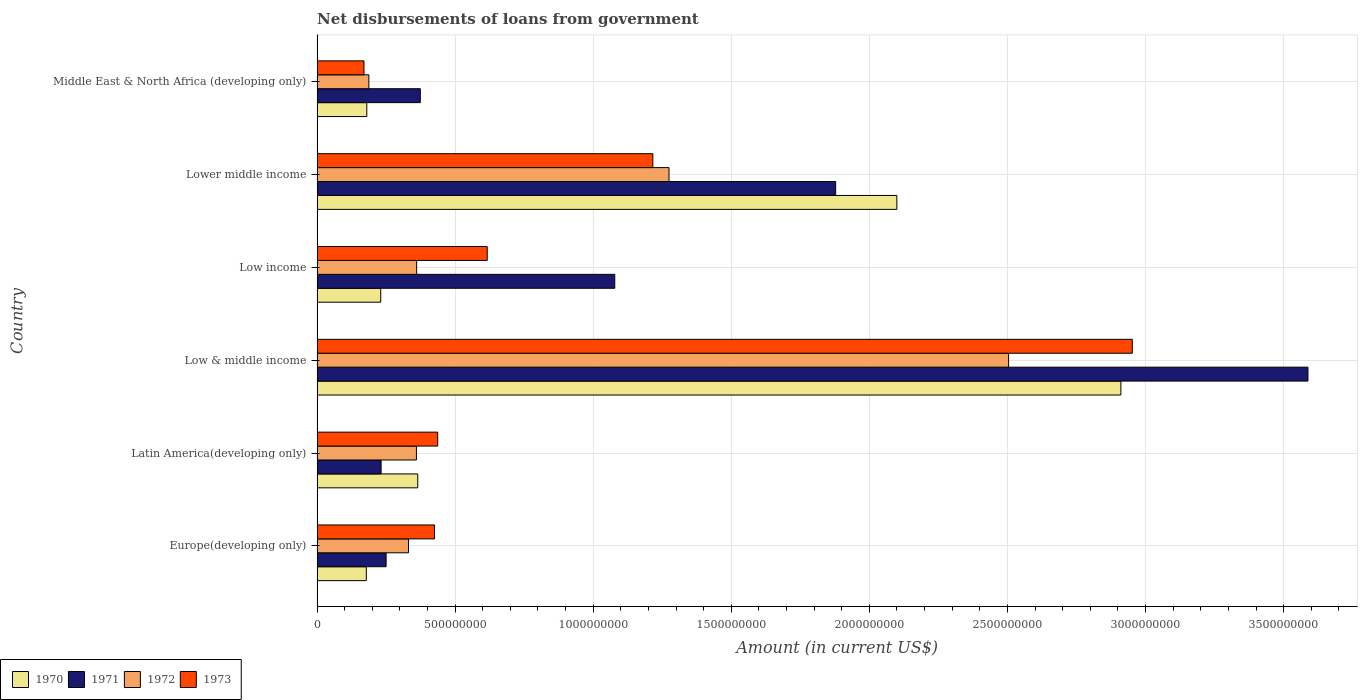Are the number of bars on each tick of the Y-axis equal?
Offer a terse response. Yes. How many bars are there on the 5th tick from the top?
Your response must be concise. 4. How many bars are there on the 5th tick from the bottom?
Your answer should be very brief. 4. What is the label of the 2nd group of bars from the top?
Your response must be concise. Lower middle income. What is the amount of loan disbursed from government in 1971 in Latin America(developing only)?
Provide a short and direct response. 2.32e+08. Across all countries, what is the maximum amount of loan disbursed from government in 1971?
Offer a very short reply. 3.59e+09. Across all countries, what is the minimum amount of loan disbursed from government in 1971?
Ensure brevity in your answer.  2.32e+08. In which country was the amount of loan disbursed from government in 1970 maximum?
Ensure brevity in your answer.  Low & middle income. In which country was the amount of loan disbursed from government in 1970 minimum?
Your answer should be compact. Europe(developing only). What is the total amount of loan disbursed from government in 1971 in the graph?
Provide a succinct answer. 7.40e+09. What is the difference between the amount of loan disbursed from government in 1973 in Low & middle income and that in Lower middle income?
Your answer should be very brief. 1.74e+09. What is the difference between the amount of loan disbursed from government in 1970 in Middle East & North Africa (developing only) and the amount of loan disbursed from government in 1973 in Low income?
Make the answer very short. -4.36e+08. What is the average amount of loan disbursed from government in 1973 per country?
Give a very brief answer. 9.69e+08. What is the difference between the amount of loan disbursed from government in 1972 and amount of loan disbursed from government in 1970 in Lower middle income?
Provide a succinct answer. -8.25e+08. In how many countries, is the amount of loan disbursed from government in 1973 greater than 1300000000 US$?
Make the answer very short. 1. What is the ratio of the amount of loan disbursed from government in 1971 in Europe(developing only) to that in Middle East & North Africa (developing only)?
Make the answer very short. 0.67. Is the difference between the amount of loan disbursed from government in 1972 in Latin America(developing only) and Low & middle income greater than the difference between the amount of loan disbursed from government in 1970 in Latin America(developing only) and Low & middle income?
Your answer should be compact. Yes. What is the difference between the highest and the second highest amount of loan disbursed from government in 1971?
Make the answer very short. 1.71e+09. What is the difference between the highest and the lowest amount of loan disbursed from government in 1970?
Offer a very short reply. 2.73e+09. In how many countries, is the amount of loan disbursed from government in 1972 greater than the average amount of loan disbursed from government in 1972 taken over all countries?
Provide a succinct answer. 2. Is it the case that in every country, the sum of the amount of loan disbursed from government in 1970 and amount of loan disbursed from government in 1972 is greater than the amount of loan disbursed from government in 1971?
Offer a very short reply. No. How many bars are there?
Your response must be concise. 24. Are all the bars in the graph horizontal?
Keep it short and to the point. Yes. How many countries are there in the graph?
Your response must be concise. 6. Are the values on the major ticks of X-axis written in scientific E-notation?
Provide a succinct answer. No. Does the graph contain grids?
Your answer should be very brief. Yes. Where does the legend appear in the graph?
Offer a very short reply. Bottom left. How many legend labels are there?
Provide a succinct answer. 4. How are the legend labels stacked?
Your answer should be very brief. Horizontal. What is the title of the graph?
Provide a succinct answer. Net disbursements of loans from government. What is the label or title of the X-axis?
Keep it short and to the point. Amount (in current US$). What is the label or title of the Y-axis?
Your answer should be very brief. Country. What is the Amount (in current US$) of 1970 in Europe(developing only)?
Ensure brevity in your answer.  1.78e+08. What is the Amount (in current US$) of 1971 in Europe(developing only)?
Give a very brief answer. 2.50e+08. What is the Amount (in current US$) of 1972 in Europe(developing only)?
Keep it short and to the point. 3.31e+08. What is the Amount (in current US$) in 1973 in Europe(developing only)?
Your answer should be compact. 4.25e+08. What is the Amount (in current US$) in 1970 in Latin America(developing only)?
Offer a terse response. 3.65e+08. What is the Amount (in current US$) of 1971 in Latin America(developing only)?
Provide a succinct answer. 2.32e+08. What is the Amount (in current US$) in 1972 in Latin America(developing only)?
Offer a terse response. 3.60e+08. What is the Amount (in current US$) in 1973 in Latin America(developing only)?
Give a very brief answer. 4.37e+08. What is the Amount (in current US$) in 1970 in Low & middle income?
Provide a succinct answer. 2.91e+09. What is the Amount (in current US$) of 1971 in Low & middle income?
Make the answer very short. 3.59e+09. What is the Amount (in current US$) of 1972 in Low & middle income?
Keep it short and to the point. 2.50e+09. What is the Amount (in current US$) of 1973 in Low & middle income?
Your answer should be compact. 2.95e+09. What is the Amount (in current US$) in 1970 in Low income?
Your answer should be very brief. 2.31e+08. What is the Amount (in current US$) in 1971 in Low income?
Keep it short and to the point. 1.08e+09. What is the Amount (in current US$) of 1972 in Low income?
Your answer should be very brief. 3.61e+08. What is the Amount (in current US$) in 1973 in Low income?
Make the answer very short. 6.16e+08. What is the Amount (in current US$) of 1970 in Lower middle income?
Your answer should be very brief. 2.10e+09. What is the Amount (in current US$) in 1971 in Lower middle income?
Give a very brief answer. 1.88e+09. What is the Amount (in current US$) of 1972 in Lower middle income?
Offer a very short reply. 1.27e+09. What is the Amount (in current US$) of 1973 in Lower middle income?
Make the answer very short. 1.22e+09. What is the Amount (in current US$) of 1970 in Middle East & North Africa (developing only)?
Provide a short and direct response. 1.80e+08. What is the Amount (in current US$) in 1971 in Middle East & North Africa (developing only)?
Your answer should be very brief. 3.74e+08. What is the Amount (in current US$) in 1972 in Middle East & North Africa (developing only)?
Offer a very short reply. 1.88e+08. What is the Amount (in current US$) of 1973 in Middle East & North Africa (developing only)?
Provide a short and direct response. 1.70e+08. Across all countries, what is the maximum Amount (in current US$) in 1970?
Offer a terse response. 2.91e+09. Across all countries, what is the maximum Amount (in current US$) in 1971?
Ensure brevity in your answer.  3.59e+09. Across all countries, what is the maximum Amount (in current US$) of 1972?
Keep it short and to the point. 2.50e+09. Across all countries, what is the maximum Amount (in current US$) of 1973?
Make the answer very short. 2.95e+09. Across all countries, what is the minimum Amount (in current US$) in 1970?
Your response must be concise. 1.78e+08. Across all countries, what is the minimum Amount (in current US$) in 1971?
Your response must be concise. 2.32e+08. Across all countries, what is the minimum Amount (in current US$) in 1972?
Provide a short and direct response. 1.88e+08. Across all countries, what is the minimum Amount (in current US$) in 1973?
Your answer should be compact. 1.70e+08. What is the total Amount (in current US$) in 1970 in the graph?
Offer a very short reply. 5.96e+09. What is the total Amount (in current US$) in 1971 in the graph?
Your answer should be compact. 7.40e+09. What is the total Amount (in current US$) of 1972 in the graph?
Give a very brief answer. 5.02e+09. What is the total Amount (in current US$) of 1973 in the graph?
Your response must be concise. 5.82e+09. What is the difference between the Amount (in current US$) of 1970 in Europe(developing only) and that in Latin America(developing only)?
Offer a terse response. -1.86e+08. What is the difference between the Amount (in current US$) in 1971 in Europe(developing only) and that in Latin America(developing only)?
Your answer should be compact. 1.82e+07. What is the difference between the Amount (in current US$) of 1972 in Europe(developing only) and that in Latin America(developing only)?
Make the answer very short. -2.88e+07. What is the difference between the Amount (in current US$) in 1973 in Europe(developing only) and that in Latin America(developing only)?
Provide a succinct answer. -1.16e+07. What is the difference between the Amount (in current US$) of 1970 in Europe(developing only) and that in Low & middle income?
Make the answer very short. -2.73e+09. What is the difference between the Amount (in current US$) in 1971 in Europe(developing only) and that in Low & middle income?
Offer a very short reply. -3.34e+09. What is the difference between the Amount (in current US$) of 1972 in Europe(developing only) and that in Low & middle income?
Make the answer very short. -2.17e+09. What is the difference between the Amount (in current US$) of 1973 in Europe(developing only) and that in Low & middle income?
Your answer should be compact. -2.53e+09. What is the difference between the Amount (in current US$) in 1970 in Europe(developing only) and that in Low income?
Provide a short and direct response. -5.22e+07. What is the difference between the Amount (in current US$) in 1971 in Europe(developing only) and that in Low income?
Your answer should be compact. -8.28e+08. What is the difference between the Amount (in current US$) of 1972 in Europe(developing only) and that in Low income?
Offer a very short reply. -2.96e+07. What is the difference between the Amount (in current US$) in 1973 in Europe(developing only) and that in Low income?
Your answer should be compact. -1.91e+08. What is the difference between the Amount (in current US$) in 1970 in Europe(developing only) and that in Lower middle income?
Ensure brevity in your answer.  -1.92e+09. What is the difference between the Amount (in current US$) in 1971 in Europe(developing only) and that in Lower middle income?
Offer a very short reply. -1.63e+09. What is the difference between the Amount (in current US$) in 1972 in Europe(developing only) and that in Lower middle income?
Your response must be concise. -9.43e+08. What is the difference between the Amount (in current US$) in 1973 in Europe(developing only) and that in Lower middle income?
Offer a very short reply. -7.91e+08. What is the difference between the Amount (in current US$) of 1970 in Europe(developing only) and that in Middle East & North Africa (developing only)?
Provide a short and direct response. -1.75e+06. What is the difference between the Amount (in current US$) in 1971 in Europe(developing only) and that in Middle East & North Africa (developing only)?
Keep it short and to the point. -1.24e+08. What is the difference between the Amount (in current US$) in 1972 in Europe(developing only) and that in Middle East & North Africa (developing only)?
Keep it short and to the point. 1.43e+08. What is the difference between the Amount (in current US$) in 1973 in Europe(developing only) and that in Middle East & North Africa (developing only)?
Make the answer very short. 2.55e+08. What is the difference between the Amount (in current US$) of 1970 in Latin America(developing only) and that in Low & middle income?
Ensure brevity in your answer.  -2.55e+09. What is the difference between the Amount (in current US$) in 1971 in Latin America(developing only) and that in Low & middle income?
Provide a short and direct response. -3.36e+09. What is the difference between the Amount (in current US$) in 1972 in Latin America(developing only) and that in Low & middle income?
Offer a terse response. -2.14e+09. What is the difference between the Amount (in current US$) of 1973 in Latin America(developing only) and that in Low & middle income?
Offer a very short reply. -2.52e+09. What is the difference between the Amount (in current US$) in 1970 in Latin America(developing only) and that in Low income?
Keep it short and to the point. 1.34e+08. What is the difference between the Amount (in current US$) in 1971 in Latin America(developing only) and that in Low income?
Offer a terse response. -8.46e+08. What is the difference between the Amount (in current US$) of 1972 in Latin America(developing only) and that in Low income?
Your answer should be compact. -7.43e+05. What is the difference between the Amount (in current US$) in 1973 in Latin America(developing only) and that in Low income?
Make the answer very short. -1.79e+08. What is the difference between the Amount (in current US$) of 1970 in Latin America(developing only) and that in Lower middle income?
Keep it short and to the point. -1.73e+09. What is the difference between the Amount (in current US$) of 1971 in Latin America(developing only) and that in Lower middle income?
Keep it short and to the point. -1.65e+09. What is the difference between the Amount (in current US$) of 1972 in Latin America(developing only) and that in Lower middle income?
Your answer should be very brief. -9.15e+08. What is the difference between the Amount (in current US$) of 1973 in Latin America(developing only) and that in Lower middle income?
Offer a terse response. -7.79e+08. What is the difference between the Amount (in current US$) of 1970 in Latin America(developing only) and that in Middle East & North Africa (developing only)?
Make the answer very short. 1.85e+08. What is the difference between the Amount (in current US$) of 1971 in Latin America(developing only) and that in Middle East & North Africa (developing only)?
Give a very brief answer. -1.42e+08. What is the difference between the Amount (in current US$) in 1972 in Latin America(developing only) and that in Middle East & North Africa (developing only)?
Make the answer very short. 1.72e+08. What is the difference between the Amount (in current US$) in 1973 in Latin America(developing only) and that in Middle East & North Africa (developing only)?
Offer a very short reply. 2.67e+08. What is the difference between the Amount (in current US$) of 1970 in Low & middle income and that in Low income?
Offer a very short reply. 2.68e+09. What is the difference between the Amount (in current US$) in 1971 in Low & middle income and that in Low income?
Provide a short and direct response. 2.51e+09. What is the difference between the Amount (in current US$) of 1972 in Low & middle income and that in Low income?
Provide a short and direct response. 2.14e+09. What is the difference between the Amount (in current US$) of 1973 in Low & middle income and that in Low income?
Offer a terse response. 2.34e+09. What is the difference between the Amount (in current US$) in 1970 in Low & middle income and that in Lower middle income?
Make the answer very short. 8.11e+08. What is the difference between the Amount (in current US$) in 1971 in Low & middle income and that in Lower middle income?
Provide a short and direct response. 1.71e+09. What is the difference between the Amount (in current US$) in 1972 in Low & middle income and that in Lower middle income?
Offer a very short reply. 1.23e+09. What is the difference between the Amount (in current US$) in 1973 in Low & middle income and that in Lower middle income?
Ensure brevity in your answer.  1.74e+09. What is the difference between the Amount (in current US$) of 1970 in Low & middle income and that in Middle East & North Africa (developing only)?
Keep it short and to the point. 2.73e+09. What is the difference between the Amount (in current US$) of 1971 in Low & middle income and that in Middle East & North Africa (developing only)?
Your answer should be very brief. 3.21e+09. What is the difference between the Amount (in current US$) of 1972 in Low & middle income and that in Middle East & North Africa (developing only)?
Keep it short and to the point. 2.32e+09. What is the difference between the Amount (in current US$) in 1973 in Low & middle income and that in Middle East & North Africa (developing only)?
Give a very brief answer. 2.78e+09. What is the difference between the Amount (in current US$) in 1970 in Low income and that in Lower middle income?
Ensure brevity in your answer.  -1.87e+09. What is the difference between the Amount (in current US$) in 1971 in Low income and that in Lower middle income?
Give a very brief answer. -8.00e+08. What is the difference between the Amount (in current US$) of 1972 in Low income and that in Lower middle income?
Keep it short and to the point. -9.14e+08. What is the difference between the Amount (in current US$) in 1973 in Low income and that in Lower middle income?
Keep it short and to the point. -6.00e+08. What is the difference between the Amount (in current US$) of 1970 in Low income and that in Middle East & North Africa (developing only)?
Offer a very short reply. 5.04e+07. What is the difference between the Amount (in current US$) of 1971 in Low income and that in Middle East & North Africa (developing only)?
Your response must be concise. 7.04e+08. What is the difference between the Amount (in current US$) in 1972 in Low income and that in Middle East & North Africa (developing only)?
Your answer should be compact. 1.73e+08. What is the difference between the Amount (in current US$) of 1973 in Low income and that in Middle East & North Africa (developing only)?
Your answer should be very brief. 4.46e+08. What is the difference between the Amount (in current US$) of 1970 in Lower middle income and that in Middle East & North Africa (developing only)?
Make the answer very short. 1.92e+09. What is the difference between the Amount (in current US$) of 1971 in Lower middle income and that in Middle East & North Africa (developing only)?
Offer a terse response. 1.50e+09. What is the difference between the Amount (in current US$) of 1972 in Lower middle income and that in Middle East & North Africa (developing only)?
Offer a very short reply. 1.09e+09. What is the difference between the Amount (in current US$) of 1973 in Lower middle income and that in Middle East & North Africa (developing only)?
Provide a short and direct response. 1.05e+09. What is the difference between the Amount (in current US$) in 1970 in Europe(developing only) and the Amount (in current US$) in 1971 in Latin America(developing only)?
Make the answer very short. -5.36e+07. What is the difference between the Amount (in current US$) in 1970 in Europe(developing only) and the Amount (in current US$) in 1972 in Latin America(developing only)?
Offer a very short reply. -1.82e+08. What is the difference between the Amount (in current US$) of 1970 in Europe(developing only) and the Amount (in current US$) of 1973 in Latin America(developing only)?
Keep it short and to the point. -2.59e+08. What is the difference between the Amount (in current US$) of 1971 in Europe(developing only) and the Amount (in current US$) of 1972 in Latin America(developing only)?
Your answer should be compact. -1.10e+08. What is the difference between the Amount (in current US$) of 1971 in Europe(developing only) and the Amount (in current US$) of 1973 in Latin America(developing only)?
Provide a short and direct response. -1.87e+08. What is the difference between the Amount (in current US$) in 1972 in Europe(developing only) and the Amount (in current US$) in 1973 in Latin America(developing only)?
Keep it short and to the point. -1.06e+08. What is the difference between the Amount (in current US$) in 1970 in Europe(developing only) and the Amount (in current US$) in 1971 in Low & middle income?
Ensure brevity in your answer.  -3.41e+09. What is the difference between the Amount (in current US$) in 1970 in Europe(developing only) and the Amount (in current US$) in 1972 in Low & middle income?
Your answer should be compact. -2.33e+09. What is the difference between the Amount (in current US$) in 1970 in Europe(developing only) and the Amount (in current US$) in 1973 in Low & middle income?
Make the answer very short. -2.77e+09. What is the difference between the Amount (in current US$) in 1971 in Europe(developing only) and the Amount (in current US$) in 1972 in Low & middle income?
Provide a succinct answer. -2.25e+09. What is the difference between the Amount (in current US$) of 1971 in Europe(developing only) and the Amount (in current US$) of 1973 in Low & middle income?
Offer a very short reply. -2.70e+09. What is the difference between the Amount (in current US$) of 1972 in Europe(developing only) and the Amount (in current US$) of 1973 in Low & middle income?
Offer a terse response. -2.62e+09. What is the difference between the Amount (in current US$) in 1970 in Europe(developing only) and the Amount (in current US$) in 1971 in Low income?
Give a very brief answer. -9.00e+08. What is the difference between the Amount (in current US$) in 1970 in Europe(developing only) and the Amount (in current US$) in 1972 in Low income?
Ensure brevity in your answer.  -1.82e+08. What is the difference between the Amount (in current US$) in 1970 in Europe(developing only) and the Amount (in current US$) in 1973 in Low income?
Your answer should be compact. -4.38e+08. What is the difference between the Amount (in current US$) in 1971 in Europe(developing only) and the Amount (in current US$) in 1972 in Low income?
Provide a short and direct response. -1.11e+08. What is the difference between the Amount (in current US$) of 1971 in Europe(developing only) and the Amount (in current US$) of 1973 in Low income?
Keep it short and to the point. -3.66e+08. What is the difference between the Amount (in current US$) in 1972 in Europe(developing only) and the Amount (in current US$) in 1973 in Low income?
Keep it short and to the point. -2.85e+08. What is the difference between the Amount (in current US$) of 1970 in Europe(developing only) and the Amount (in current US$) of 1971 in Lower middle income?
Provide a short and direct response. -1.70e+09. What is the difference between the Amount (in current US$) in 1970 in Europe(developing only) and the Amount (in current US$) in 1972 in Lower middle income?
Provide a succinct answer. -1.10e+09. What is the difference between the Amount (in current US$) in 1970 in Europe(developing only) and the Amount (in current US$) in 1973 in Lower middle income?
Your response must be concise. -1.04e+09. What is the difference between the Amount (in current US$) of 1971 in Europe(developing only) and the Amount (in current US$) of 1972 in Lower middle income?
Offer a terse response. -1.02e+09. What is the difference between the Amount (in current US$) in 1971 in Europe(developing only) and the Amount (in current US$) in 1973 in Lower middle income?
Your answer should be compact. -9.66e+08. What is the difference between the Amount (in current US$) of 1972 in Europe(developing only) and the Amount (in current US$) of 1973 in Lower middle income?
Offer a very short reply. -8.85e+08. What is the difference between the Amount (in current US$) of 1970 in Europe(developing only) and the Amount (in current US$) of 1971 in Middle East & North Africa (developing only)?
Provide a short and direct response. -1.96e+08. What is the difference between the Amount (in current US$) of 1970 in Europe(developing only) and the Amount (in current US$) of 1972 in Middle East & North Africa (developing only)?
Offer a terse response. -9.22e+06. What is the difference between the Amount (in current US$) in 1970 in Europe(developing only) and the Amount (in current US$) in 1973 in Middle East & North Africa (developing only)?
Provide a short and direct response. 8.45e+06. What is the difference between the Amount (in current US$) in 1971 in Europe(developing only) and the Amount (in current US$) in 1972 in Middle East & North Africa (developing only)?
Provide a succinct answer. 6.25e+07. What is the difference between the Amount (in current US$) in 1971 in Europe(developing only) and the Amount (in current US$) in 1973 in Middle East & North Africa (developing only)?
Provide a short and direct response. 8.02e+07. What is the difference between the Amount (in current US$) of 1972 in Europe(developing only) and the Amount (in current US$) of 1973 in Middle East & North Africa (developing only)?
Ensure brevity in your answer.  1.61e+08. What is the difference between the Amount (in current US$) in 1970 in Latin America(developing only) and the Amount (in current US$) in 1971 in Low & middle income?
Provide a short and direct response. -3.22e+09. What is the difference between the Amount (in current US$) of 1970 in Latin America(developing only) and the Amount (in current US$) of 1972 in Low & middle income?
Give a very brief answer. -2.14e+09. What is the difference between the Amount (in current US$) in 1970 in Latin America(developing only) and the Amount (in current US$) in 1973 in Low & middle income?
Provide a short and direct response. -2.59e+09. What is the difference between the Amount (in current US$) in 1971 in Latin America(developing only) and the Amount (in current US$) in 1972 in Low & middle income?
Your answer should be compact. -2.27e+09. What is the difference between the Amount (in current US$) in 1971 in Latin America(developing only) and the Amount (in current US$) in 1973 in Low & middle income?
Offer a terse response. -2.72e+09. What is the difference between the Amount (in current US$) of 1972 in Latin America(developing only) and the Amount (in current US$) of 1973 in Low & middle income?
Your response must be concise. -2.59e+09. What is the difference between the Amount (in current US$) in 1970 in Latin America(developing only) and the Amount (in current US$) in 1971 in Low income?
Offer a very short reply. -7.13e+08. What is the difference between the Amount (in current US$) of 1970 in Latin America(developing only) and the Amount (in current US$) of 1972 in Low income?
Provide a succinct answer. 4.02e+06. What is the difference between the Amount (in current US$) in 1970 in Latin America(developing only) and the Amount (in current US$) in 1973 in Low income?
Make the answer very short. -2.52e+08. What is the difference between the Amount (in current US$) of 1971 in Latin America(developing only) and the Amount (in current US$) of 1972 in Low income?
Make the answer very short. -1.29e+08. What is the difference between the Amount (in current US$) in 1971 in Latin America(developing only) and the Amount (in current US$) in 1973 in Low income?
Make the answer very short. -3.84e+08. What is the difference between the Amount (in current US$) in 1972 in Latin America(developing only) and the Amount (in current US$) in 1973 in Low income?
Offer a very short reply. -2.56e+08. What is the difference between the Amount (in current US$) in 1970 in Latin America(developing only) and the Amount (in current US$) in 1971 in Lower middle income?
Give a very brief answer. -1.51e+09. What is the difference between the Amount (in current US$) in 1970 in Latin America(developing only) and the Amount (in current US$) in 1972 in Lower middle income?
Your response must be concise. -9.10e+08. What is the difference between the Amount (in current US$) in 1970 in Latin America(developing only) and the Amount (in current US$) in 1973 in Lower middle income?
Make the answer very short. -8.51e+08. What is the difference between the Amount (in current US$) of 1971 in Latin America(developing only) and the Amount (in current US$) of 1972 in Lower middle income?
Your answer should be compact. -1.04e+09. What is the difference between the Amount (in current US$) of 1971 in Latin America(developing only) and the Amount (in current US$) of 1973 in Lower middle income?
Your answer should be compact. -9.84e+08. What is the difference between the Amount (in current US$) in 1972 in Latin America(developing only) and the Amount (in current US$) in 1973 in Lower middle income?
Offer a very short reply. -8.56e+08. What is the difference between the Amount (in current US$) of 1970 in Latin America(developing only) and the Amount (in current US$) of 1971 in Middle East & North Africa (developing only)?
Give a very brief answer. -9.29e+06. What is the difference between the Amount (in current US$) of 1970 in Latin America(developing only) and the Amount (in current US$) of 1972 in Middle East & North Africa (developing only)?
Your answer should be compact. 1.77e+08. What is the difference between the Amount (in current US$) of 1970 in Latin America(developing only) and the Amount (in current US$) of 1973 in Middle East & North Africa (developing only)?
Your answer should be compact. 1.95e+08. What is the difference between the Amount (in current US$) of 1971 in Latin America(developing only) and the Amount (in current US$) of 1972 in Middle East & North Africa (developing only)?
Make the answer very short. 4.43e+07. What is the difference between the Amount (in current US$) in 1971 in Latin America(developing only) and the Amount (in current US$) in 1973 in Middle East & North Africa (developing only)?
Your answer should be compact. 6.20e+07. What is the difference between the Amount (in current US$) in 1972 in Latin America(developing only) and the Amount (in current US$) in 1973 in Middle East & North Africa (developing only)?
Make the answer very short. 1.90e+08. What is the difference between the Amount (in current US$) in 1970 in Low & middle income and the Amount (in current US$) in 1971 in Low income?
Keep it short and to the point. 1.83e+09. What is the difference between the Amount (in current US$) in 1970 in Low & middle income and the Amount (in current US$) in 1972 in Low income?
Ensure brevity in your answer.  2.55e+09. What is the difference between the Amount (in current US$) in 1970 in Low & middle income and the Amount (in current US$) in 1973 in Low income?
Your answer should be compact. 2.29e+09. What is the difference between the Amount (in current US$) of 1971 in Low & middle income and the Amount (in current US$) of 1972 in Low income?
Make the answer very short. 3.23e+09. What is the difference between the Amount (in current US$) of 1971 in Low & middle income and the Amount (in current US$) of 1973 in Low income?
Ensure brevity in your answer.  2.97e+09. What is the difference between the Amount (in current US$) in 1972 in Low & middle income and the Amount (in current US$) in 1973 in Low income?
Your answer should be compact. 1.89e+09. What is the difference between the Amount (in current US$) in 1970 in Low & middle income and the Amount (in current US$) in 1971 in Lower middle income?
Offer a very short reply. 1.03e+09. What is the difference between the Amount (in current US$) in 1970 in Low & middle income and the Amount (in current US$) in 1972 in Lower middle income?
Provide a succinct answer. 1.64e+09. What is the difference between the Amount (in current US$) in 1970 in Low & middle income and the Amount (in current US$) in 1973 in Lower middle income?
Give a very brief answer. 1.69e+09. What is the difference between the Amount (in current US$) of 1971 in Low & middle income and the Amount (in current US$) of 1972 in Lower middle income?
Offer a terse response. 2.31e+09. What is the difference between the Amount (in current US$) of 1971 in Low & middle income and the Amount (in current US$) of 1973 in Lower middle income?
Keep it short and to the point. 2.37e+09. What is the difference between the Amount (in current US$) in 1972 in Low & middle income and the Amount (in current US$) in 1973 in Lower middle income?
Make the answer very short. 1.29e+09. What is the difference between the Amount (in current US$) in 1970 in Low & middle income and the Amount (in current US$) in 1971 in Middle East & North Africa (developing only)?
Ensure brevity in your answer.  2.54e+09. What is the difference between the Amount (in current US$) of 1970 in Low & middle income and the Amount (in current US$) of 1972 in Middle East & North Africa (developing only)?
Keep it short and to the point. 2.72e+09. What is the difference between the Amount (in current US$) in 1970 in Low & middle income and the Amount (in current US$) in 1973 in Middle East & North Africa (developing only)?
Your answer should be very brief. 2.74e+09. What is the difference between the Amount (in current US$) in 1971 in Low & middle income and the Amount (in current US$) in 1972 in Middle East & North Africa (developing only)?
Keep it short and to the point. 3.40e+09. What is the difference between the Amount (in current US$) of 1971 in Low & middle income and the Amount (in current US$) of 1973 in Middle East & North Africa (developing only)?
Make the answer very short. 3.42e+09. What is the difference between the Amount (in current US$) of 1972 in Low & middle income and the Amount (in current US$) of 1973 in Middle East & North Africa (developing only)?
Offer a very short reply. 2.33e+09. What is the difference between the Amount (in current US$) in 1970 in Low income and the Amount (in current US$) in 1971 in Lower middle income?
Make the answer very short. -1.65e+09. What is the difference between the Amount (in current US$) in 1970 in Low income and the Amount (in current US$) in 1972 in Lower middle income?
Your answer should be compact. -1.04e+09. What is the difference between the Amount (in current US$) of 1970 in Low income and the Amount (in current US$) of 1973 in Lower middle income?
Provide a short and direct response. -9.85e+08. What is the difference between the Amount (in current US$) of 1971 in Low income and the Amount (in current US$) of 1972 in Lower middle income?
Your response must be concise. -1.96e+08. What is the difference between the Amount (in current US$) of 1971 in Low income and the Amount (in current US$) of 1973 in Lower middle income?
Offer a terse response. -1.38e+08. What is the difference between the Amount (in current US$) of 1972 in Low income and the Amount (in current US$) of 1973 in Lower middle income?
Your response must be concise. -8.55e+08. What is the difference between the Amount (in current US$) of 1970 in Low income and the Amount (in current US$) of 1971 in Middle East & North Africa (developing only)?
Your response must be concise. -1.43e+08. What is the difference between the Amount (in current US$) in 1970 in Low income and the Amount (in current US$) in 1972 in Middle East & North Africa (developing only)?
Ensure brevity in your answer.  4.30e+07. What is the difference between the Amount (in current US$) in 1970 in Low income and the Amount (in current US$) in 1973 in Middle East & North Africa (developing only)?
Your answer should be compact. 6.06e+07. What is the difference between the Amount (in current US$) in 1971 in Low income and the Amount (in current US$) in 1972 in Middle East & North Africa (developing only)?
Your answer should be compact. 8.90e+08. What is the difference between the Amount (in current US$) in 1971 in Low income and the Amount (in current US$) in 1973 in Middle East & North Africa (developing only)?
Offer a very short reply. 9.08e+08. What is the difference between the Amount (in current US$) of 1972 in Low income and the Amount (in current US$) of 1973 in Middle East & North Africa (developing only)?
Your response must be concise. 1.91e+08. What is the difference between the Amount (in current US$) in 1970 in Lower middle income and the Amount (in current US$) in 1971 in Middle East & North Africa (developing only)?
Keep it short and to the point. 1.73e+09. What is the difference between the Amount (in current US$) of 1970 in Lower middle income and the Amount (in current US$) of 1972 in Middle East & North Africa (developing only)?
Your answer should be very brief. 1.91e+09. What is the difference between the Amount (in current US$) of 1970 in Lower middle income and the Amount (in current US$) of 1973 in Middle East & North Africa (developing only)?
Provide a short and direct response. 1.93e+09. What is the difference between the Amount (in current US$) in 1971 in Lower middle income and the Amount (in current US$) in 1972 in Middle East & North Africa (developing only)?
Ensure brevity in your answer.  1.69e+09. What is the difference between the Amount (in current US$) of 1971 in Lower middle income and the Amount (in current US$) of 1973 in Middle East & North Africa (developing only)?
Offer a terse response. 1.71e+09. What is the difference between the Amount (in current US$) in 1972 in Lower middle income and the Amount (in current US$) in 1973 in Middle East & North Africa (developing only)?
Your response must be concise. 1.10e+09. What is the average Amount (in current US$) of 1970 per country?
Make the answer very short. 9.94e+08. What is the average Amount (in current US$) in 1971 per country?
Provide a succinct answer. 1.23e+09. What is the average Amount (in current US$) of 1972 per country?
Offer a very short reply. 8.36e+08. What is the average Amount (in current US$) of 1973 per country?
Your answer should be very brief. 9.69e+08. What is the difference between the Amount (in current US$) in 1970 and Amount (in current US$) in 1971 in Europe(developing only)?
Your answer should be very brief. -7.17e+07. What is the difference between the Amount (in current US$) of 1970 and Amount (in current US$) of 1972 in Europe(developing only)?
Keep it short and to the point. -1.53e+08. What is the difference between the Amount (in current US$) in 1970 and Amount (in current US$) in 1973 in Europe(developing only)?
Your answer should be very brief. -2.47e+08. What is the difference between the Amount (in current US$) in 1971 and Amount (in current US$) in 1972 in Europe(developing only)?
Give a very brief answer. -8.10e+07. What is the difference between the Amount (in current US$) of 1971 and Amount (in current US$) of 1973 in Europe(developing only)?
Your answer should be compact. -1.75e+08. What is the difference between the Amount (in current US$) in 1972 and Amount (in current US$) in 1973 in Europe(developing only)?
Offer a very short reply. -9.42e+07. What is the difference between the Amount (in current US$) in 1970 and Amount (in current US$) in 1971 in Latin America(developing only)?
Keep it short and to the point. 1.33e+08. What is the difference between the Amount (in current US$) of 1970 and Amount (in current US$) of 1972 in Latin America(developing only)?
Your answer should be very brief. 4.76e+06. What is the difference between the Amount (in current US$) of 1970 and Amount (in current US$) of 1973 in Latin America(developing only)?
Your answer should be compact. -7.22e+07. What is the difference between the Amount (in current US$) of 1971 and Amount (in current US$) of 1972 in Latin America(developing only)?
Make the answer very short. -1.28e+08. What is the difference between the Amount (in current US$) of 1971 and Amount (in current US$) of 1973 in Latin America(developing only)?
Offer a very short reply. -2.05e+08. What is the difference between the Amount (in current US$) in 1972 and Amount (in current US$) in 1973 in Latin America(developing only)?
Your response must be concise. -7.70e+07. What is the difference between the Amount (in current US$) in 1970 and Amount (in current US$) in 1971 in Low & middle income?
Provide a succinct answer. -6.77e+08. What is the difference between the Amount (in current US$) in 1970 and Amount (in current US$) in 1972 in Low & middle income?
Provide a succinct answer. 4.07e+08. What is the difference between the Amount (in current US$) of 1970 and Amount (in current US$) of 1973 in Low & middle income?
Your answer should be compact. -4.13e+07. What is the difference between the Amount (in current US$) of 1971 and Amount (in current US$) of 1972 in Low & middle income?
Provide a succinct answer. 1.08e+09. What is the difference between the Amount (in current US$) in 1971 and Amount (in current US$) in 1973 in Low & middle income?
Ensure brevity in your answer.  6.36e+08. What is the difference between the Amount (in current US$) of 1972 and Amount (in current US$) of 1973 in Low & middle income?
Ensure brevity in your answer.  -4.48e+08. What is the difference between the Amount (in current US$) in 1970 and Amount (in current US$) in 1971 in Low income?
Offer a terse response. -8.48e+08. What is the difference between the Amount (in current US$) in 1970 and Amount (in current US$) in 1972 in Low income?
Offer a terse response. -1.30e+08. What is the difference between the Amount (in current US$) of 1970 and Amount (in current US$) of 1973 in Low income?
Your answer should be compact. -3.86e+08. What is the difference between the Amount (in current US$) in 1971 and Amount (in current US$) in 1972 in Low income?
Your answer should be very brief. 7.17e+08. What is the difference between the Amount (in current US$) in 1971 and Amount (in current US$) in 1973 in Low income?
Keep it short and to the point. 4.62e+08. What is the difference between the Amount (in current US$) of 1972 and Amount (in current US$) of 1973 in Low income?
Offer a terse response. -2.56e+08. What is the difference between the Amount (in current US$) in 1970 and Amount (in current US$) in 1971 in Lower middle income?
Provide a short and direct response. 2.22e+08. What is the difference between the Amount (in current US$) in 1970 and Amount (in current US$) in 1972 in Lower middle income?
Provide a short and direct response. 8.25e+08. What is the difference between the Amount (in current US$) in 1970 and Amount (in current US$) in 1973 in Lower middle income?
Ensure brevity in your answer.  8.84e+08. What is the difference between the Amount (in current US$) in 1971 and Amount (in current US$) in 1972 in Lower middle income?
Give a very brief answer. 6.03e+08. What is the difference between the Amount (in current US$) of 1971 and Amount (in current US$) of 1973 in Lower middle income?
Make the answer very short. 6.62e+08. What is the difference between the Amount (in current US$) of 1972 and Amount (in current US$) of 1973 in Lower middle income?
Ensure brevity in your answer.  5.86e+07. What is the difference between the Amount (in current US$) in 1970 and Amount (in current US$) in 1971 in Middle East & North Africa (developing only)?
Offer a terse response. -1.94e+08. What is the difference between the Amount (in current US$) in 1970 and Amount (in current US$) in 1972 in Middle East & North Africa (developing only)?
Provide a succinct answer. -7.47e+06. What is the difference between the Amount (in current US$) in 1970 and Amount (in current US$) in 1973 in Middle East & North Africa (developing only)?
Ensure brevity in your answer.  1.02e+07. What is the difference between the Amount (in current US$) of 1971 and Amount (in current US$) of 1972 in Middle East & North Africa (developing only)?
Ensure brevity in your answer.  1.86e+08. What is the difference between the Amount (in current US$) of 1971 and Amount (in current US$) of 1973 in Middle East & North Africa (developing only)?
Offer a very short reply. 2.04e+08. What is the difference between the Amount (in current US$) in 1972 and Amount (in current US$) in 1973 in Middle East & North Africa (developing only)?
Offer a terse response. 1.77e+07. What is the ratio of the Amount (in current US$) in 1970 in Europe(developing only) to that in Latin America(developing only)?
Give a very brief answer. 0.49. What is the ratio of the Amount (in current US$) in 1971 in Europe(developing only) to that in Latin America(developing only)?
Offer a terse response. 1.08. What is the ratio of the Amount (in current US$) in 1973 in Europe(developing only) to that in Latin America(developing only)?
Your response must be concise. 0.97. What is the ratio of the Amount (in current US$) in 1970 in Europe(developing only) to that in Low & middle income?
Offer a very short reply. 0.06. What is the ratio of the Amount (in current US$) in 1971 in Europe(developing only) to that in Low & middle income?
Provide a short and direct response. 0.07. What is the ratio of the Amount (in current US$) of 1972 in Europe(developing only) to that in Low & middle income?
Provide a short and direct response. 0.13. What is the ratio of the Amount (in current US$) in 1973 in Europe(developing only) to that in Low & middle income?
Offer a terse response. 0.14. What is the ratio of the Amount (in current US$) in 1970 in Europe(developing only) to that in Low income?
Provide a short and direct response. 0.77. What is the ratio of the Amount (in current US$) in 1971 in Europe(developing only) to that in Low income?
Make the answer very short. 0.23. What is the ratio of the Amount (in current US$) in 1972 in Europe(developing only) to that in Low income?
Your answer should be very brief. 0.92. What is the ratio of the Amount (in current US$) in 1973 in Europe(developing only) to that in Low income?
Provide a short and direct response. 0.69. What is the ratio of the Amount (in current US$) of 1970 in Europe(developing only) to that in Lower middle income?
Give a very brief answer. 0.09. What is the ratio of the Amount (in current US$) of 1971 in Europe(developing only) to that in Lower middle income?
Your response must be concise. 0.13. What is the ratio of the Amount (in current US$) in 1972 in Europe(developing only) to that in Lower middle income?
Your response must be concise. 0.26. What is the ratio of the Amount (in current US$) of 1973 in Europe(developing only) to that in Lower middle income?
Provide a succinct answer. 0.35. What is the ratio of the Amount (in current US$) in 1970 in Europe(developing only) to that in Middle East & North Africa (developing only)?
Provide a short and direct response. 0.99. What is the ratio of the Amount (in current US$) of 1971 in Europe(developing only) to that in Middle East & North Africa (developing only)?
Ensure brevity in your answer.  0.67. What is the ratio of the Amount (in current US$) of 1972 in Europe(developing only) to that in Middle East & North Africa (developing only)?
Your response must be concise. 1.76. What is the ratio of the Amount (in current US$) of 1973 in Europe(developing only) to that in Middle East & North Africa (developing only)?
Your answer should be compact. 2.5. What is the ratio of the Amount (in current US$) of 1970 in Latin America(developing only) to that in Low & middle income?
Ensure brevity in your answer.  0.13. What is the ratio of the Amount (in current US$) in 1971 in Latin America(developing only) to that in Low & middle income?
Offer a very short reply. 0.06. What is the ratio of the Amount (in current US$) in 1972 in Latin America(developing only) to that in Low & middle income?
Your answer should be compact. 0.14. What is the ratio of the Amount (in current US$) in 1973 in Latin America(developing only) to that in Low & middle income?
Offer a terse response. 0.15. What is the ratio of the Amount (in current US$) in 1970 in Latin America(developing only) to that in Low income?
Ensure brevity in your answer.  1.58. What is the ratio of the Amount (in current US$) in 1971 in Latin America(developing only) to that in Low income?
Make the answer very short. 0.22. What is the ratio of the Amount (in current US$) in 1973 in Latin America(developing only) to that in Low income?
Keep it short and to the point. 0.71. What is the ratio of the Amount (in current US$) of 1970 in Latin America(developing only) to that in Lower middle income?
Provide a short and direct response. 0.17. What is the ratio of the Amount (in current US$) of 1971 in Latin America(developing only) to that in Lower middle income?
Ensure brevity in your answer.  0.12. What is the ratio of the Amount (in current US$) of 1972 in Latin America(developing only) to that in Lower middle income?
Keep it short and to the point. 0.28. What is the ratio of the Amount (in current US$) of 1973 in Latin America(developing only) to that in Lower middle income?
Ensure brevity in your answer.  0.36. What is the ratio of the Amount (in current US$) of 1970 in Latin America(developing only) to that in Middle East & North Africa (developing only)?
Your answer should be compact. 2.02. What is the ratio of the Amount (in current US$) of 1971 in Latin America(developing only) to that in Middle East & North Africa (developing only)?
Provide a short and direct response. 0.62. What is the ratio of the Amount (in current US$) in 1972 in Latin America(developing only) to that in Middle East & North Africa (developing only)?
Provide a short and direct response. 1.92. What is the ratio of the Amount (in current US$) in 1973 in Latin America(developing only) to that in Middle East & North Africa (developing only)?
Ensure brevity in your answer.  2.57. What is the ratio of the Amount (in current US$) in 1970 in Low & middle income to that in Low income?
Keep it short and to the point. 12.63. What is the ratio of the Amount (in current US$) of 1971 in Low & middle income to that in Low income?
Your response must be concise. 3.33. What is the ratio of the Amount (in current US$) in 1972 in Low & middle income to that in Low income?
Offer a terse response. 6.94. What is the ratio of the Amount (in current US$) of 1973 in Low & middle income to that in Low income?
Give a very brief answer. 4.79. What is the ratio of the Amount (in current US$) of 1970 in Low & middle income to that in Lower middle income?
Provide a succinct answer. 1.39. What is the ratio of the Amount (in current US$) in 1971 in Low & middle income to that in Lower middle income?
Offer a terse response. 1.91. What is the ratio of the Amount (in current US$) in 1972 in Low & middle income to that in Lower middle income?
Your response must be concise. 1.96. What is the ratio of the Amount (in current US$) of 1973 in Low & middle income to that in Lower middle income?
Provide a succinct answer. 2.43. What is the ratio of the Amount (in current US$) of 1970 in Low & middle income to that in Middle East & North Africa (developing only)?
Provide a short and direct response. 16.16. What is the ratio of the Amount (in current US$) of 1971 in Low & middle income to that in Middle East & North Africa (developing only)?
Provide a short and direct response. 9.6. What is the ratio of the Amount (in current US$) of 1972 in Low & middle income to that in Middle East & North Africa (developing only)?
Provide a succinct answer. 13.35. What is the ratio of the Amount (in current US$) of 1973 in Low & middle income to that in Middle East & North Africa (developing only)?
Provide a succinct answer. 17.37. What is the ratio of the Amount (in current US$) in 1970 in Low income to that in Lower middle income?
Ensure brevity in your answer.  0.11. What is the ratio of the Amount (in current US$) of 1971 in Low income to that in Lower middle income?
Your response must be concise. 0.57. What is the ratio of the Amount (in current US$) in 1972 in Low income to that in Lower middle income?
Provide a succinct answer. 0.28. What is the ratio of the Amount (in current US$) in 1973 in Low income to that in Lower middle income?
Give a very brief answer. 0.51. What is the ratio of the Amount (in current US$) in 1970 in Low income to that in Middle East & North Africa (developing only)?
Offer a very short reply. 1.28. What is the ratio of the Amount (in current US$) of 1971 in Low income to that in Middle East & North Africa (developing only)?
Offer a very short reply. 2.88. What is the ratio of the Amount (in current US$) in 1972 in Low income to that in Middle East & North Africa (developing only)?
Offer a very short reply. 1.92. What is the ratio of the Amount (in current US$) of 1973 in Low income to that in Middle East & North Africa (developing only)?
Offer a very short reply. 3.63. What is the ratio of the Amount (in current US$) in 1970 in Lower middle income to that in Middle East & North Africa (developing only)?
Your response must be concise. 11.66. What is the ratio of the Amount (in current US$) in 1971 in Lower middle income to that in Middle East & North Africa (developing only)?
Keep it short and to the point. 5.02. What is the ratio of the Amount (in current US$) of 1972 in Lower middle income to that in Middle East & North Africa (developing only)?
Ensure brevity in your answer.  6.79. What is the ratio of the Amount (in current US$) of 1973 in Lower middle income to that in Middle East & North Africa (developing only)?
Provide a short and direct response. 7.16. What is the difference between the highest and the second highest Amount (in current US$) of 1970?
Offer a very short reply. 8.11e+08. What is the difference between the highest and the second highest Amount (in current US$) in 1971?
Make the answer very short. 1.71e+09. What is the difference between the highest and the second highest Amount (in current US$) in 1972?
Give a very brief answer. 1.23e+09. What is the difference between the highest and the second highest Amount (in current US$) of 1973?
Provide a short and direct response. 1.74e+09. What is the difference between the highest and the lowest Amount (in current US$) of 1970?
Ensure brevity in your answer.  2.73e+09. What is the difference between the highest and the lowest Amount (in current US$) of 1971?
Provide a short and direct response. 3.36e+09. What is the difference between the highest and the lowest Amount (in current US$) of 1972?
Your response must be concise. 2.32e+09. What is the difference between the highest and the lowest Amount (in current US$) of 1973?
Your answer should be compact. 2.78e+09. 